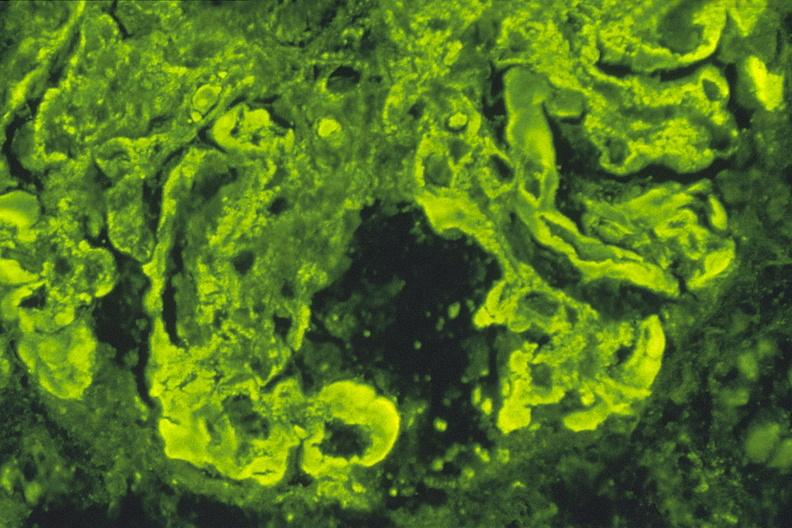what is present?
Answer the question using a single word or phrase. Urinary 